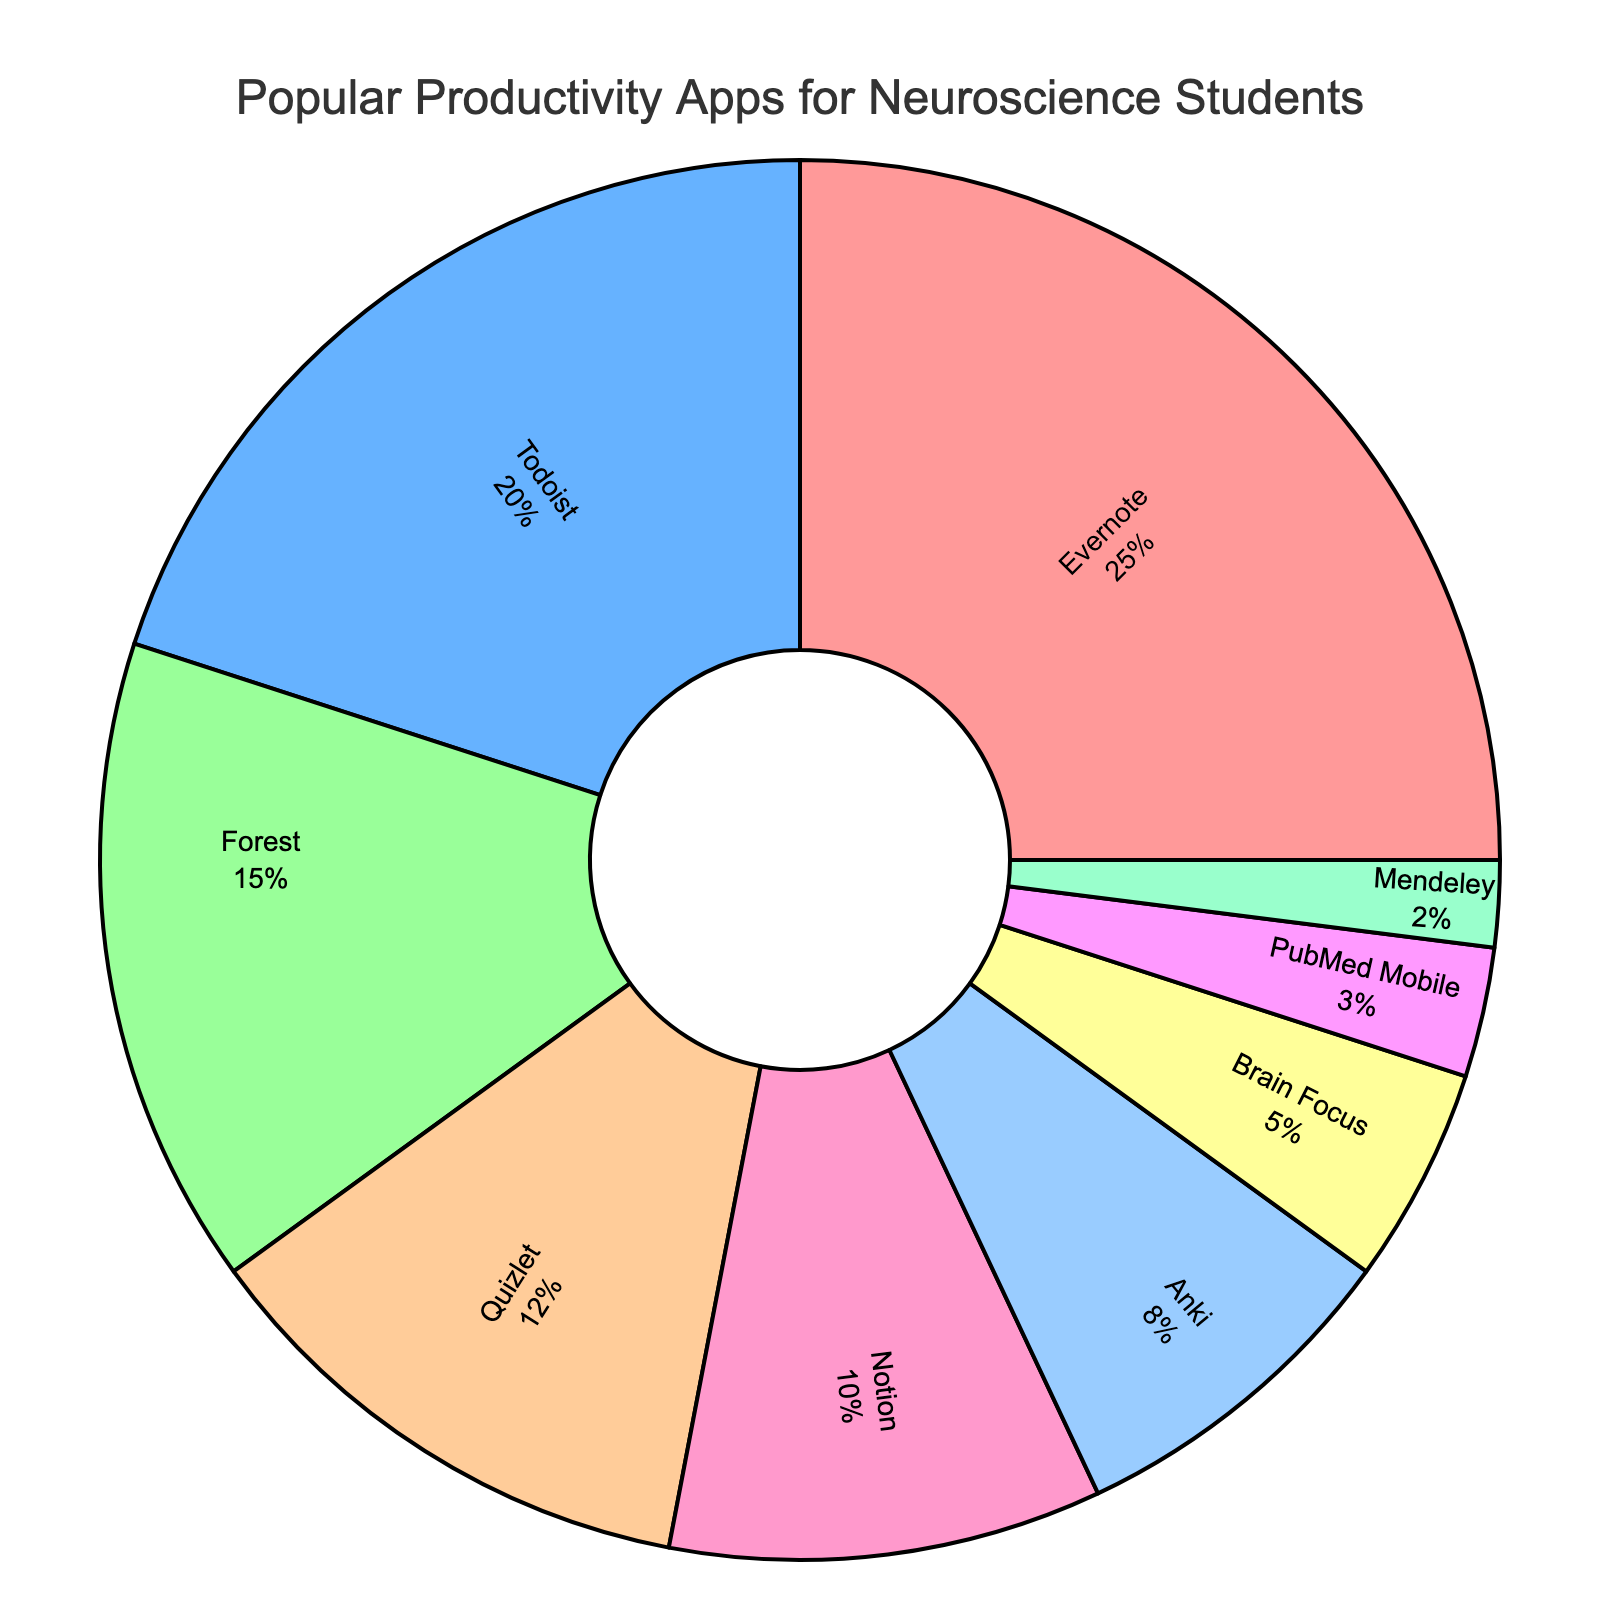What is the most commonly used productivity app among neuroscience students? Evernote occupies the largest slice of the pie chart. The segment representing Evernote is visibly the biggest compared to all other app segments.
Answer: Evernote Which app is used more: Quizlet or Forest? By comparing the pie slices, the segment for Forest is larger than the segment for Quizlet. Forest has 15% and Quizlet has 12%, indicating Forest is used more.
Answer: Forest What is the total percentage represented by Anki, Brain Focus, PubMed Mobile, and Mendeley? To find out the combined percentage, sum the values for Anki (8%), Brain Focus (5%), PubMed Mobile (3%), and Mendeley (2%). 8 + 5 + 3 + 2 = 18
Answer: 18% How does the usage of Notion compare to Todoist? Notion has a smaller segment in the pie chart compared to Todoist. Todoist represents 20% while Notion is at 10%, meaning Todoist is used twice as much as Notion.
Answer: Todoist is used twice as much What fraction of the chart is represented by productivity apps that each have less than 10% usage? Add the percentages of Notion (10%), Anki (8%), Brain Focus (5%), PubMed Mobile (3%), and Mendeley (2%). 10 + 8 + 5 + 3 + 2 = 28. Thus, 28% of the chart is represented by these apps.
Answer: 28% Considering Forest and Quizlet together, do they account for a larger percentage than Todoist alone? Sum the percentages for Forest (15%) and Quizlet (12%) to get 27%. Compare this with Todoist's percentage (20%). 27% is greater than 20%, so Forest and Quizlet together account for a larger percentage than Todoist alone.
Answer: Yes Which app's usage percentage is closest to one-fourth of the total? One-fourth of 100% is 25%. Comparing the percentages given, Evernote is exactly 25%, making it the closest to one-fourth of the total usage.
Answer: Evernote How many more percentage points does Evernote have compared to PubMed Mobile and Mendeley combined? Sum the percentages for PubMed Mobile (3%) and Mendeley (2%) to get 5%. Subtract this from Evernote’s 25%. 25 - 5 = 20
Answer: 20% What percentage of the chart do Todoist, Forest, and Quizlet cover together? Sum the percentages for Todoist (20%), Forest (15%), and Quizlet (12%). 20 + 15 + 12 = 47
Answer: 47% If you combine the percentage of the three least-used apps, what is the resulting percentage? Add the percentages for PubMed Mobile (3%), Mendeley (2%), and Brain Focus (5%). 3 + 2 + 5 = 10
Answer: 10% 